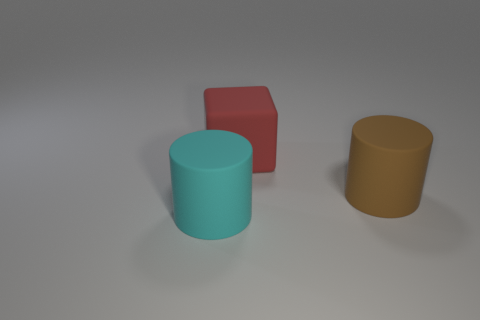How many other big things are the same shape as the large brown rubber object? There is one object that shares the same cylindrical shape as the large brown object – the blue cylinder. 